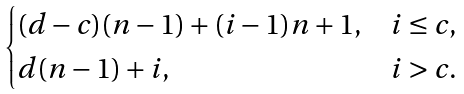<formula> <loc_0><loc_0><loc_500><loc_500>\begin{cases} ( d - c ) ( n - 1 ) + ( i - 1 ) n + 1 , & i \leq c , \\ d ( n - 1 ) + i , & i > c . \end{cases}</formula> 